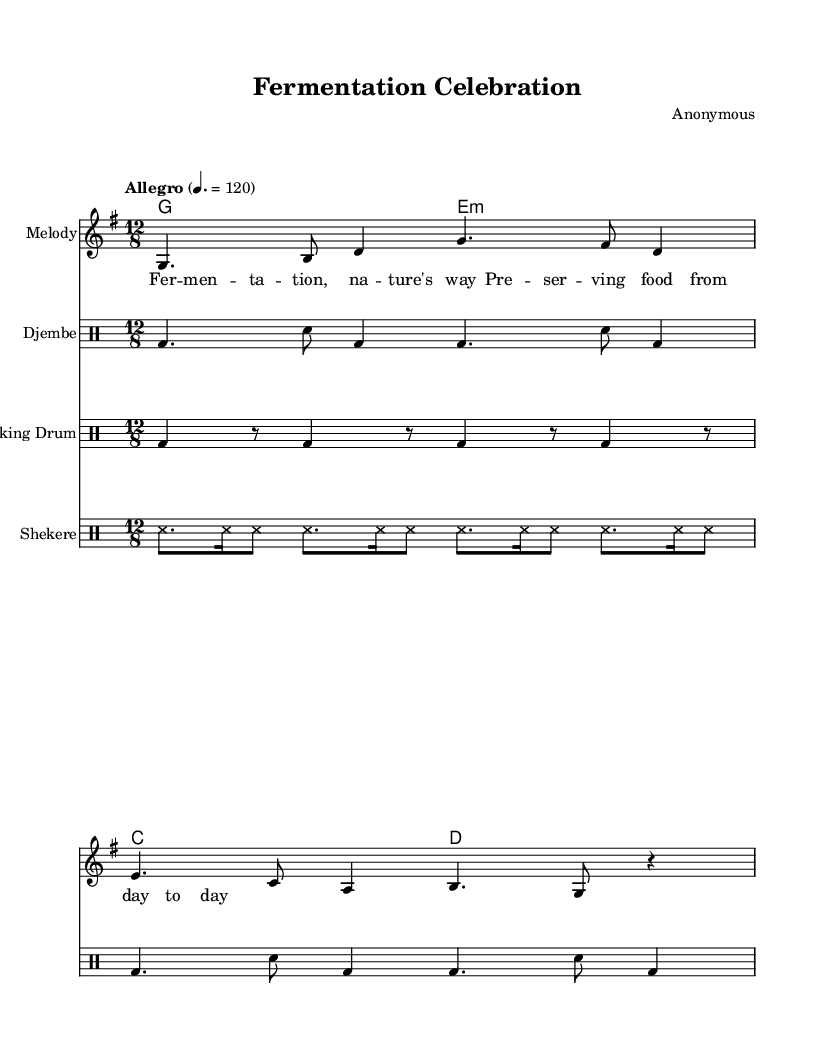What is the key signature of this music? The key signature is G major, which includes one sharp (F#). This can be determined by looking at the beginning of the sheet music where the key signature is notated.
Answer: G major What is the time signature of this music? The time signature is 12/8, indicated at the beginning of the score. It quantifies the number of beats in each measure and the type of note that gets the beat. In this case, there are 12 eighth notes per measure.
Answer: 12/8 What is the tempo marking for this piece? The tempo is marked as "Allegro" with a beat of quarter note equals 120. This indicates that the piece should be played quickly, and can be seen marked at the start of the sheet music.
Answer: Allegro How many distinct percussion instruments are used in this piece? There are three distinct percussion instruments: djembe, talking drum, and shekere. Each is labeled on separate drum staffs, clearly distinguishing them within the score.
Answer: Three What is the lyric's main theme in the song? The lyrics revolve around the theme of fermentation as a method of food preservation, highlighting its natural occurrence and daily relevance in food. This can be inferred by reading the words set above the melody.
Answer: Fermentation What rhythmic feel is portrayed in this piece? The piece features a swing feel typical of West African music, which is characterized by syncopation and polyrhythms found in the djembe, talking drum, and shekere parts. The 12/8 time signature also suggests a compound feel.
Answer: Swing What is the role of the shekere in this composition? The shekere serves as a rhythmic accompaniment that enhances the texture and provides a variety of sounds through its distinct shaking and striking technique. It can be identified in the drum staff specifically allocated to it.
Answer: Rhythmic accompaniment 